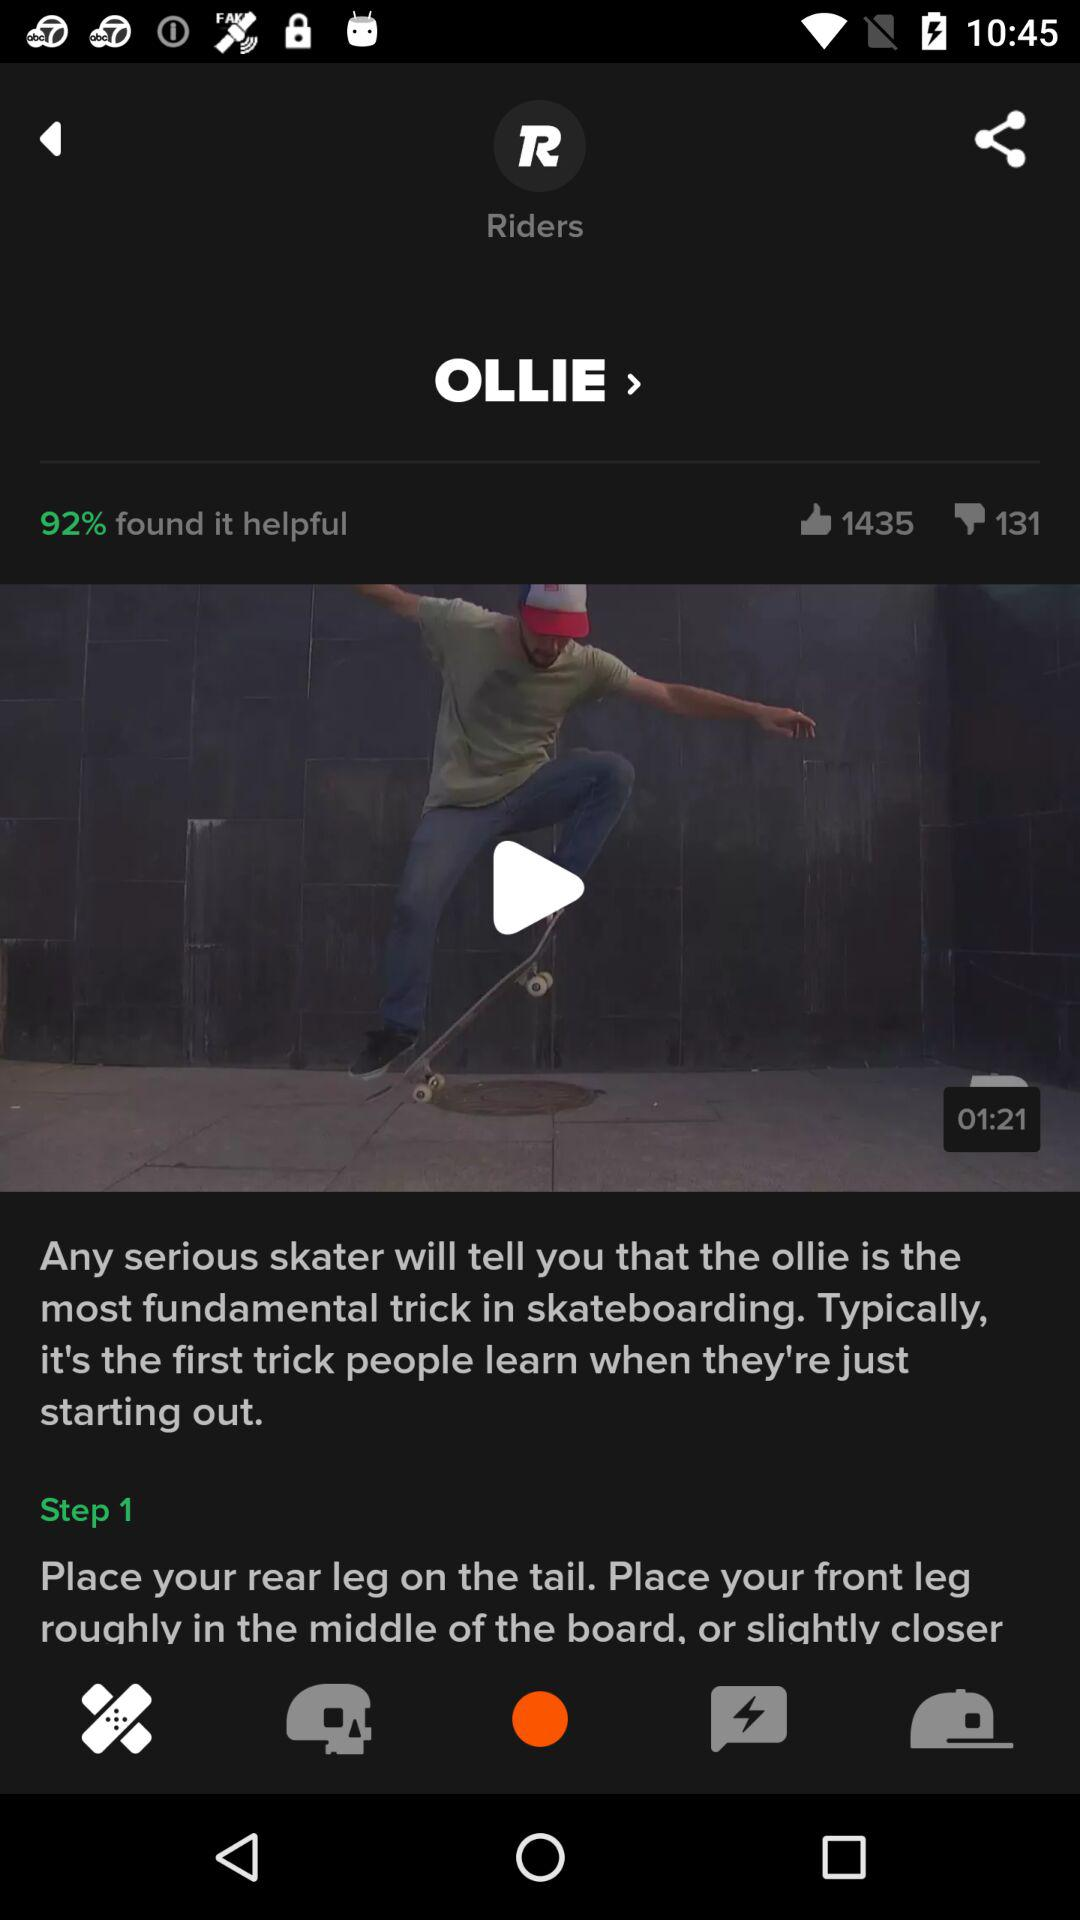What is the number of likes? The number of likes is 1435. 